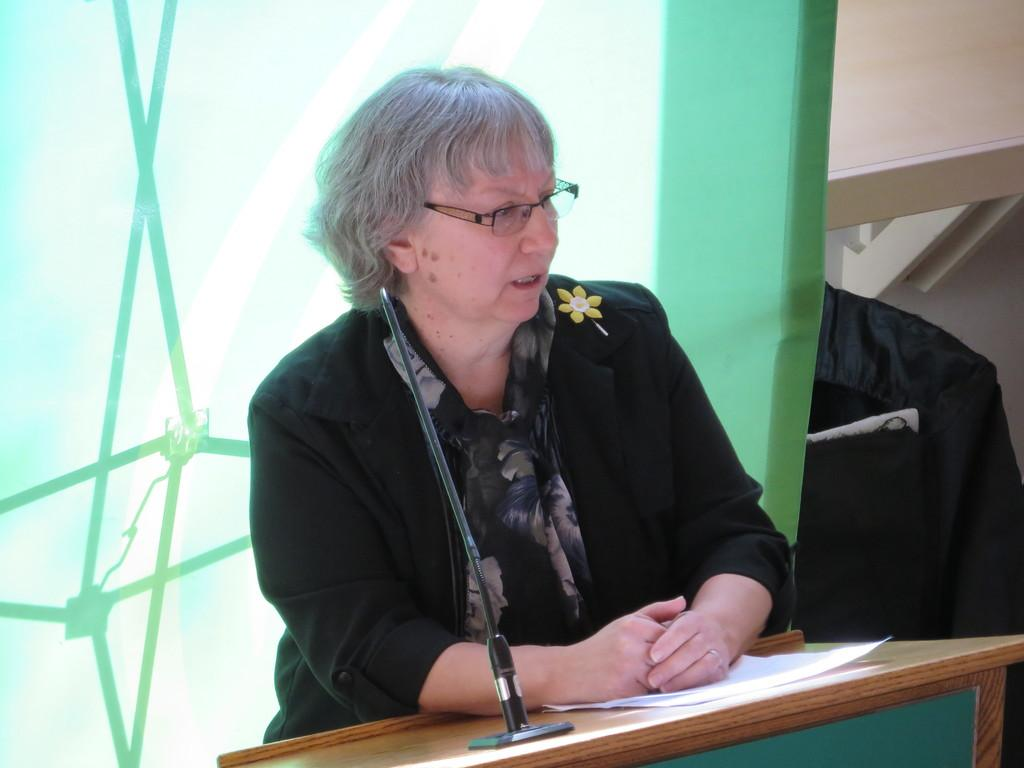Who is the main subject in the image? There is a woman in the image. What is the woman wearing? The woman is wearing a black coat. What is the woman standing near in the image? The woman is standing at a wooden speech desk. What can be seen in the background of the image? There is a green color glass in the background. Can you tell me how many snakes are slithering around the woman's feet in the image? There are no snakes present in the image; the woman is standing at a wooden speech desk. 